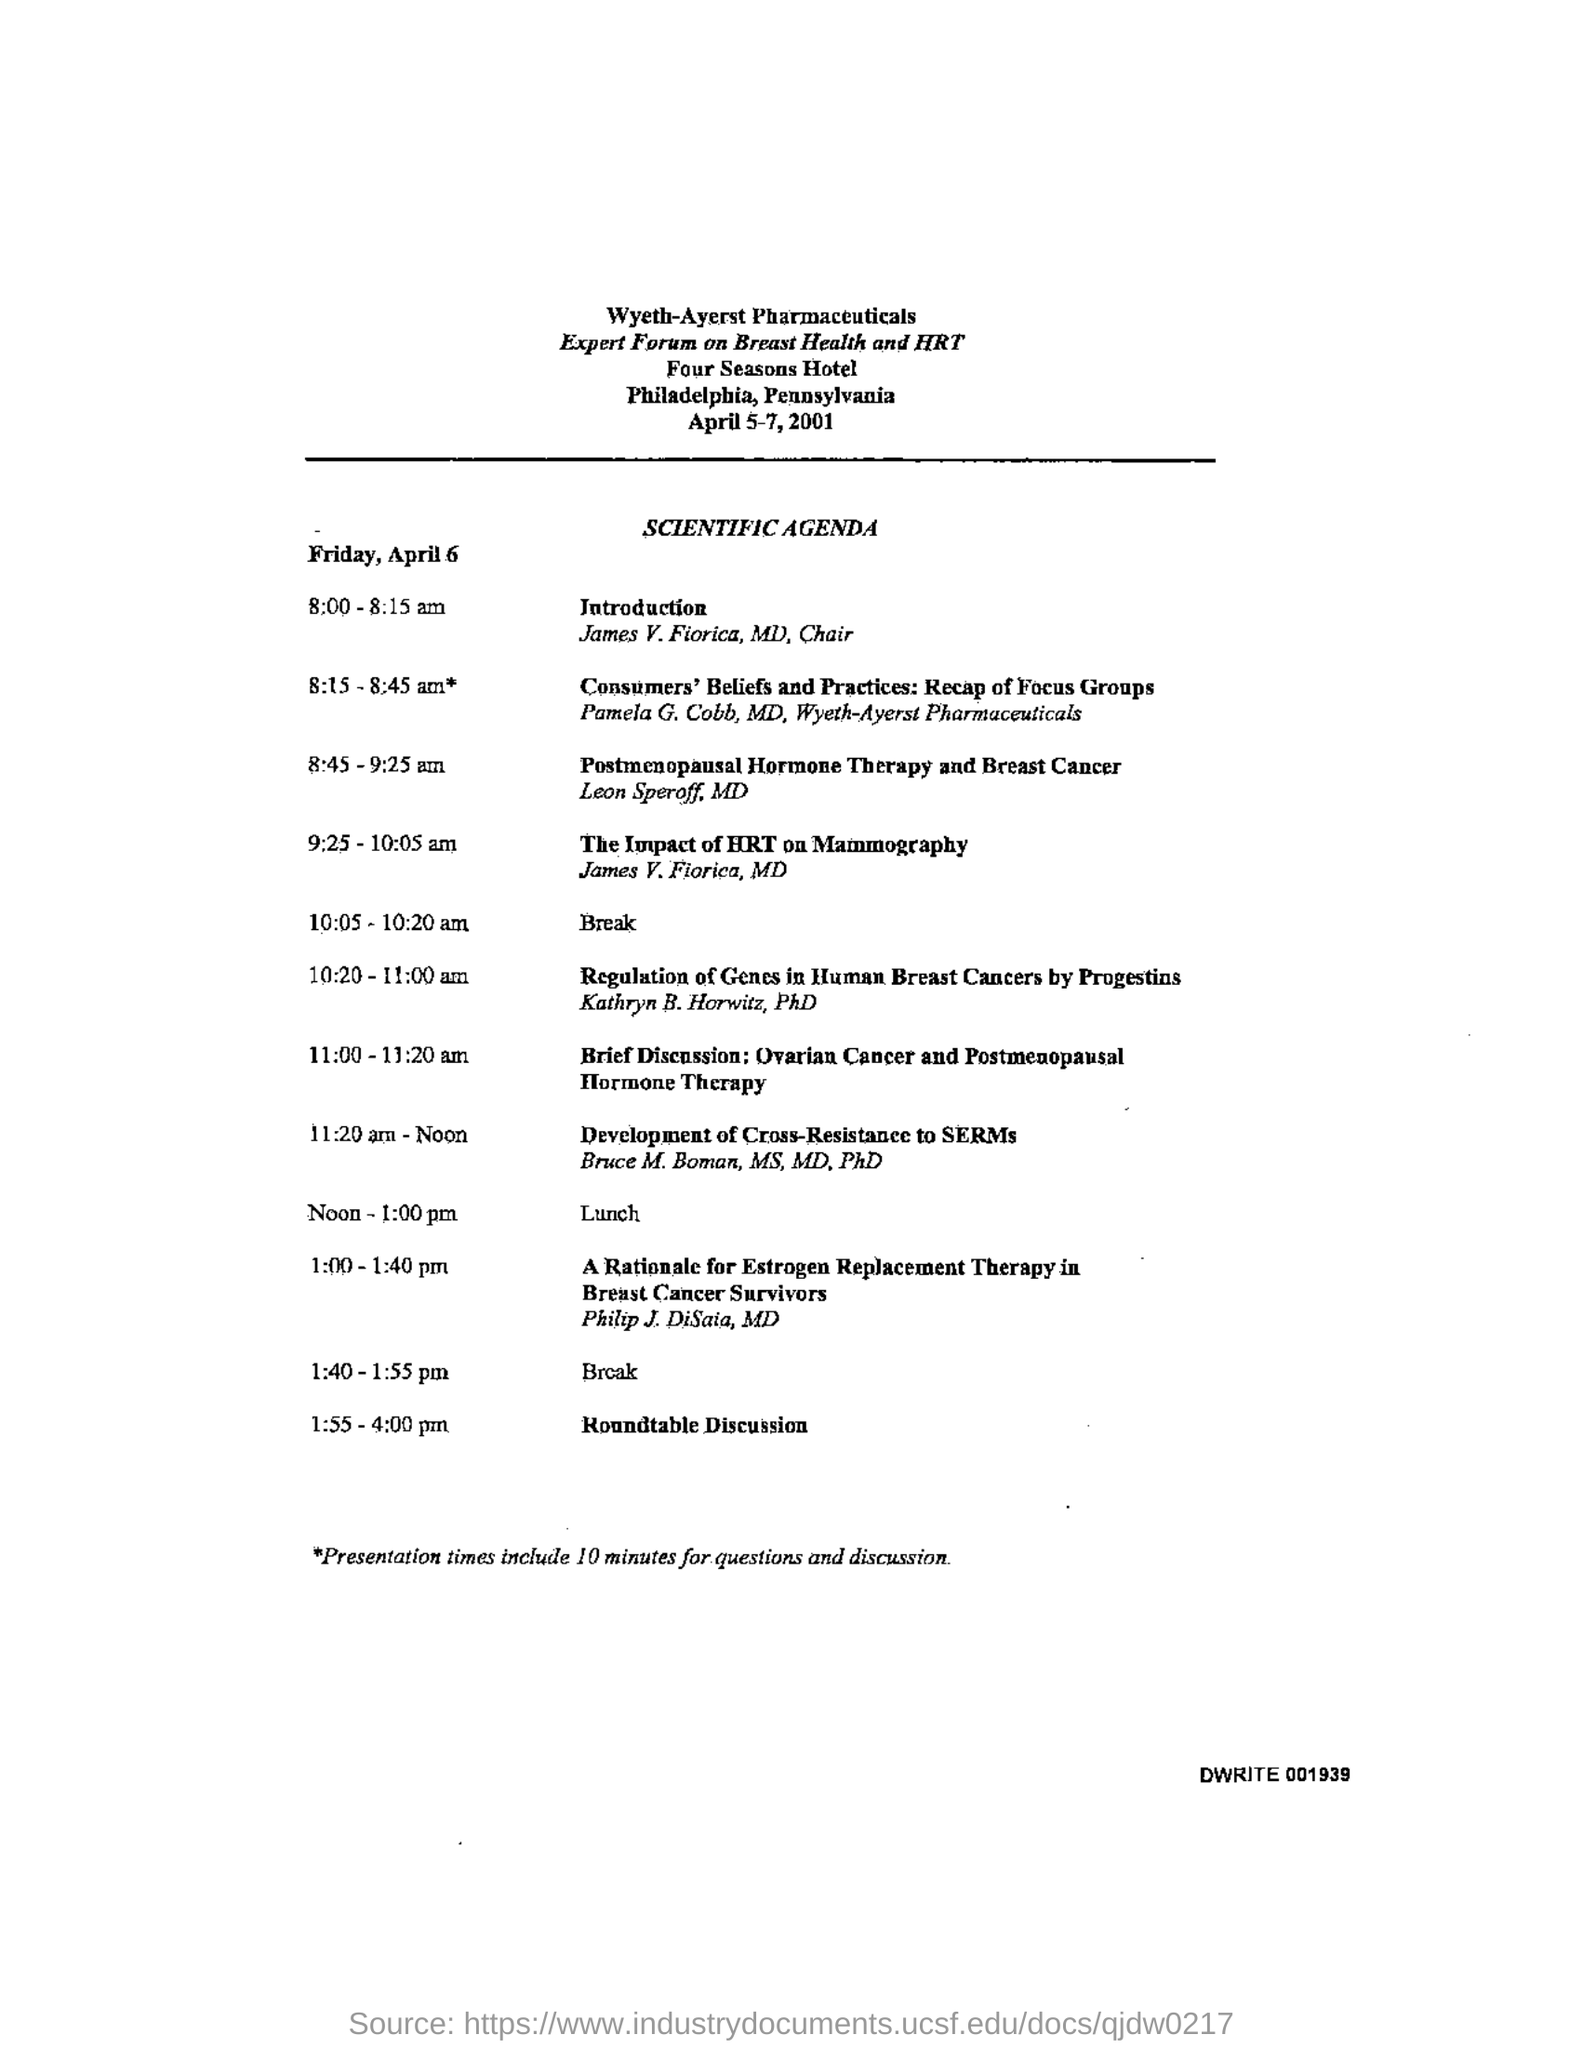When is the forum scheduled for?
Provide a short and direct response. April 5-7, 2001. Where is the forum held at?
Make the answer very short. Four Seasons Hotel. What is the location of four seasons hotel?
Give a very brief answer. Philadelphia. What time is the Introduction?
Offer a very short reply. 8:00 - 8:15 am. Who is Doing the introduction?
Provide a succinct answer. James V. Fiorica. When is the lunch?
Your answer should be compact. Noon - 1:00 pm. When is the Roundtable discussions?
Your response must be concise. 1:55 - 4:00 pm. How much time is there for questions and discussions?
Make the answer very short. 10 minutes. 